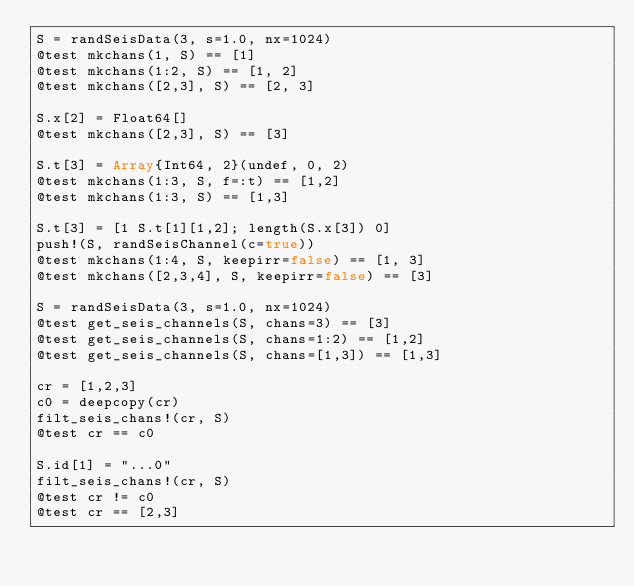<code> <loc_0><loc_0><loc_500><loc_500><_Julia_>S = randSeisData(3, s=1.0, nx=1024)
@test mkchans(1, S) == [1]
@test mkchans(1:2, S) == [1, 2]
@test mkchans([2,3], S) == [2, 3]

S.x[2] = Float64[]
@test mkchans([2,3], S) == [3]

S.t[3] = Array{Int64, 2}(undef, 0, 2)
@test mkchans(1:3, S, f=:t) == [1,2]
@test mkchans(1:3, S) == [1,3]

S.t[3] = [1 S.t[1][1,2]; length(S.x[3]) 0]
push!(S, randSeisChannel(c=true))
@test mkchans(1:4, S, keepirr=false) == [1, 3]
@test mkchans([2,3,4], S, keepirr=false) == [3]

S = randSeisData(3, s=1.0, nx=1024)
@test get_seis_channels(S, chans=3) == [3]
@test get_seis_channels(S, chans=1:2) == [1,2]
@test get_seis_channels(S, chans=[1,3]) == [1,3]

cr = [1,2,3]
c0 = deepcopy(cr)
filt_seis_chans!(cr, S)
@test cr == c0

S.id[1] = "...0"
filt_seis_chans!(cr, S)
@test cr != c0
@test cr == [2,3]
</code> 